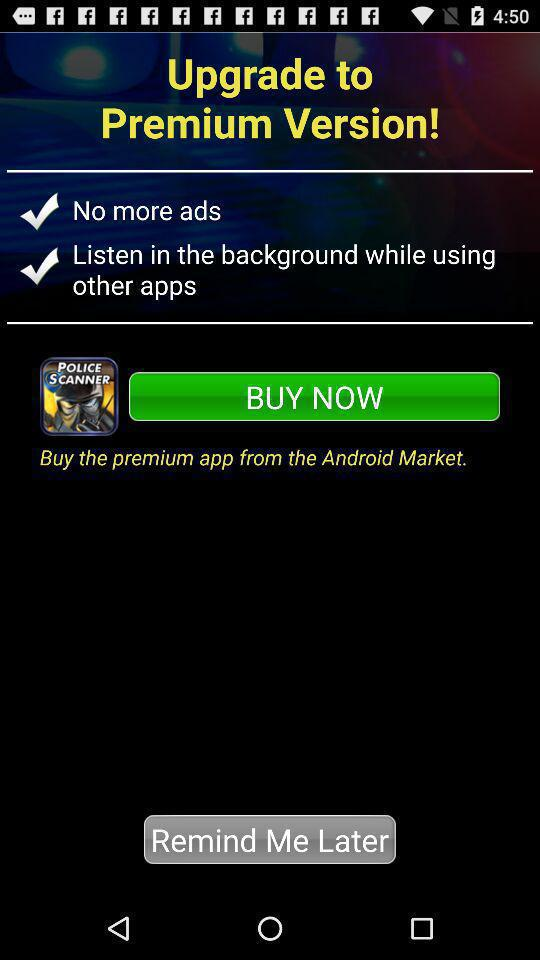How many premium features are available?
Answer the question using a single word or phrase. 2 